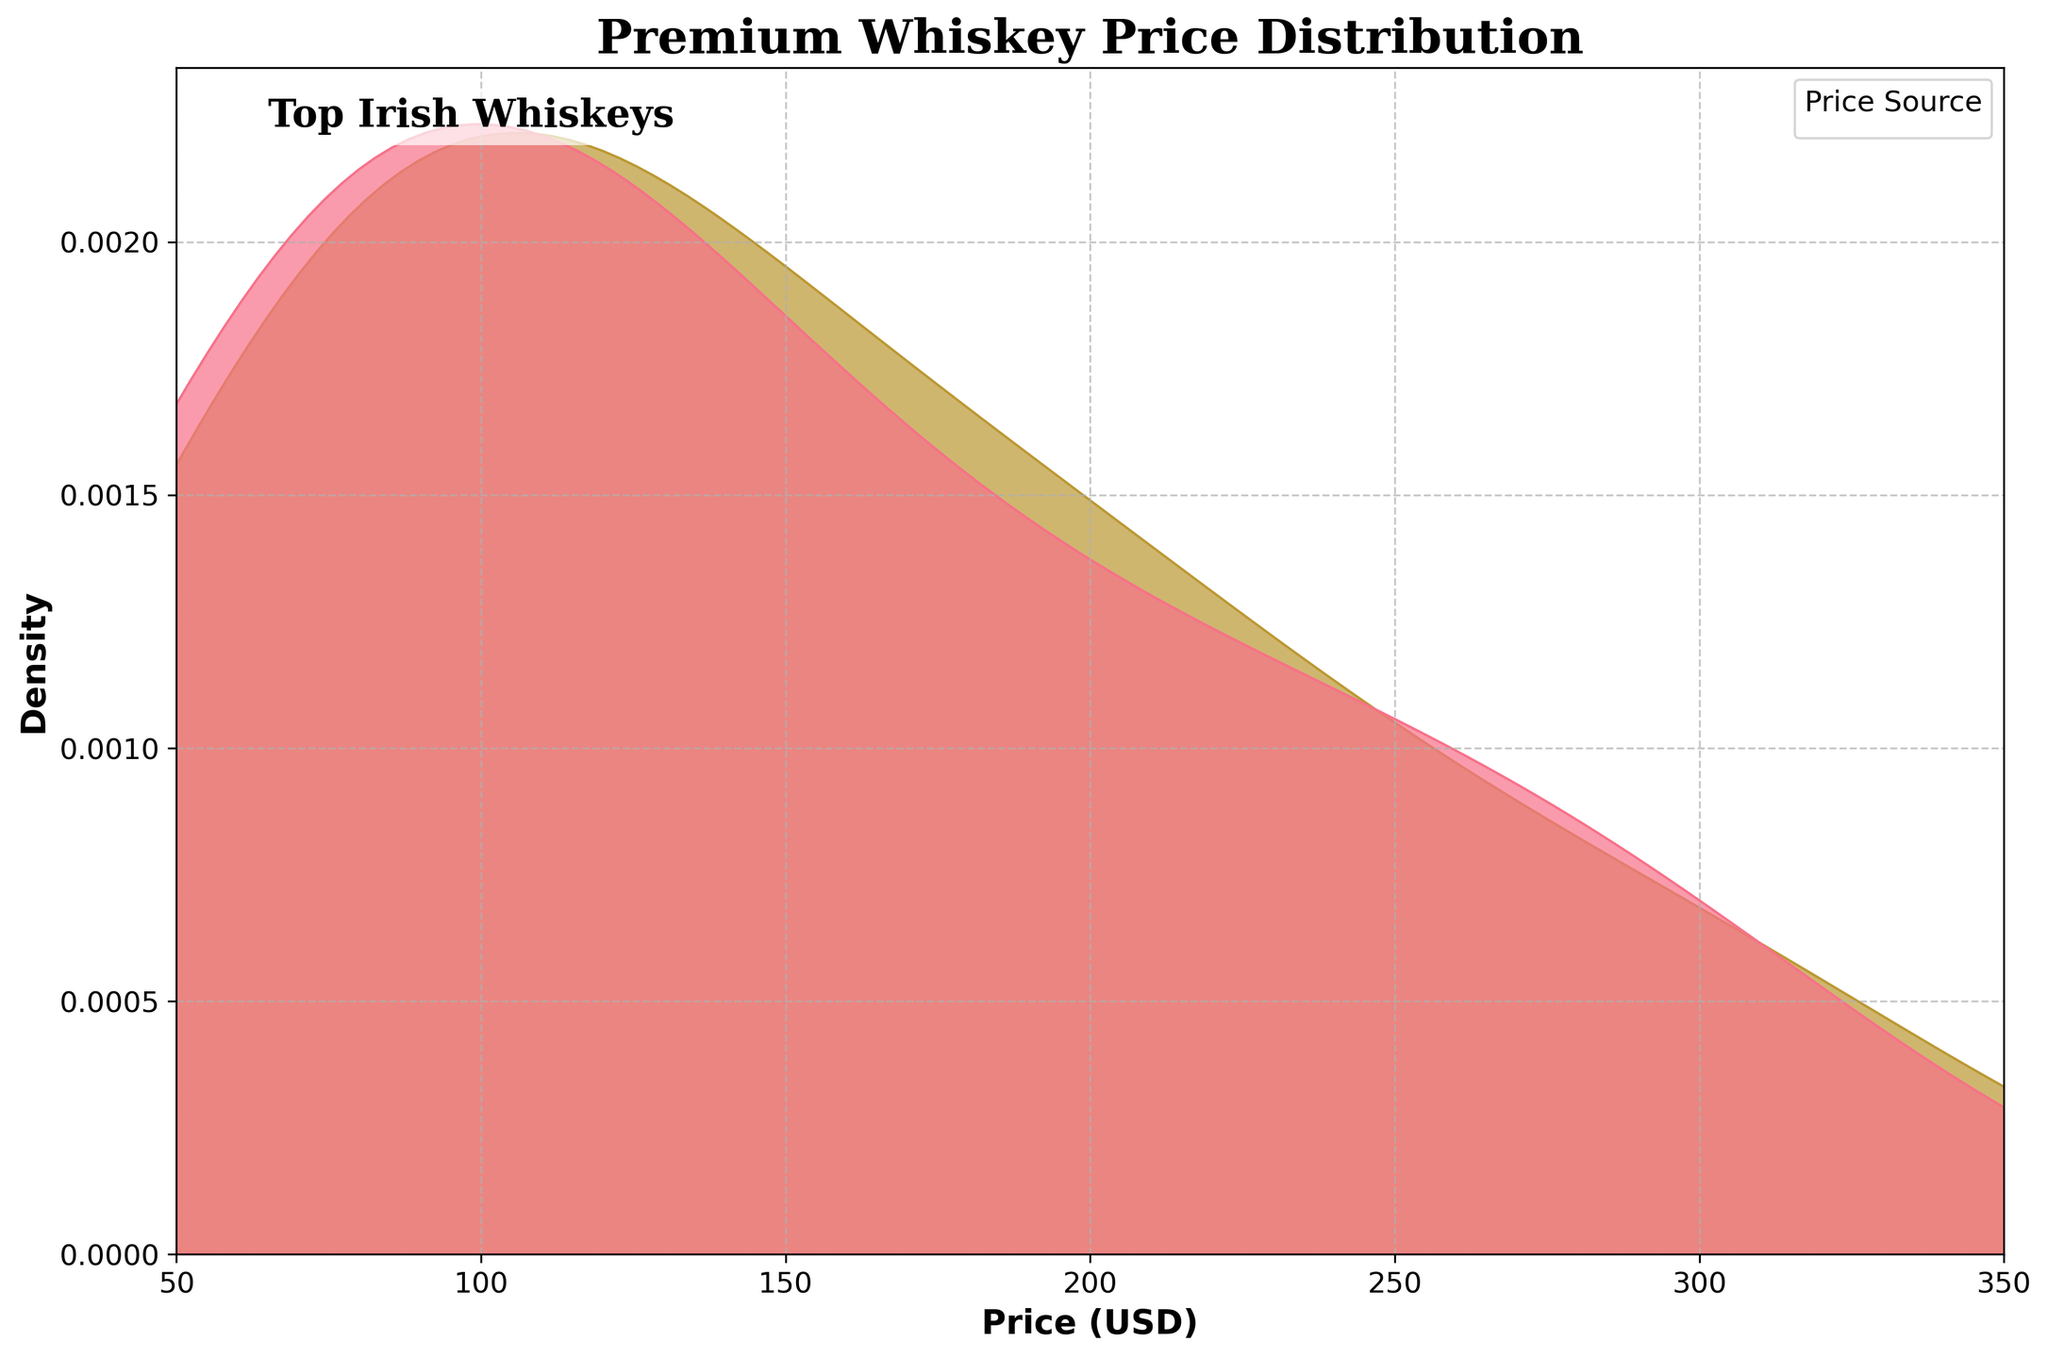What's the title of the figure? Look at the top of the plot to find the title. The bold text indicates the title.
Answer: Premium Whiskey Price Distribution What's the x-axis label of the figure? Look directly below the horizontal axis to see the label describing it.
Answer: Price (USD) Does the local liquor store or the online retailer have a wider price distribution? Observe the width of the shaded areas corresponding to each price source. The wider the shaded area, the wider the price distribution.
Answer: Online Retailer What range of prices do the premium whiskey brands exhibit in local stores? Identify the start and end of the shaded region for the local store on the x-axis.
Answer: 60 to 300 USD What price has the highest density for online retailers? Look for the peak of the density curve for online retailers. The x-axis value at the peak indicates the price with the highest density.
Answer: Around 90 USD Is the density higher for local stores or online retailers around 200 USD? Compare the heights of the density curves for each price source at 200 USD.
Answer: Local Stores Which price source shows a higher density below 100 USD? Compare the density curves below 100 USD and identify which has the higher peaks or areas.
Answer: Online Retailers What is the overall trend in whiskey prices for both local stores and online retailers? Observe the shapes and peaks of both density curves to identify general trends such as main price clusters and density drops.
Answer: Most prices cluster between 60 to 300 USD, with specific peaks around certain price points How do the density plots for local stores and online retailers compare in the 150-250 USD range? Focus on the density curves between 150 and 250 USD and compare their shapes and heights in this range.
Answer: Local stores have a higher density Which price range is least represented in the density plot? Look for the region between 50 and 350 USD where both density curves have the lowest values or flats.
Answer: 250-300 USD 